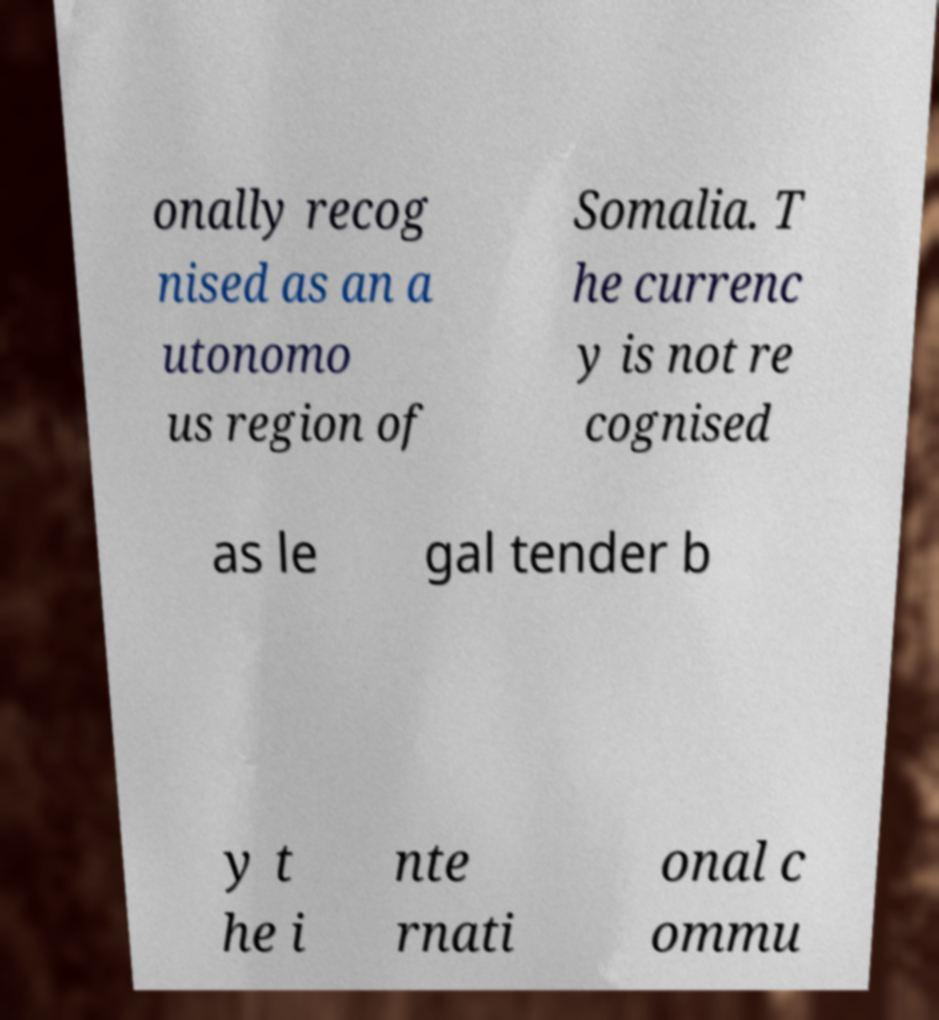What messages or text are displayed in this image? I need them in a readable, typed format. onally recog nised as an a utonomo us region of Somalia. T he currenc y is not re cognised as le gal tender b y t he i nte rnati onal c ommu 